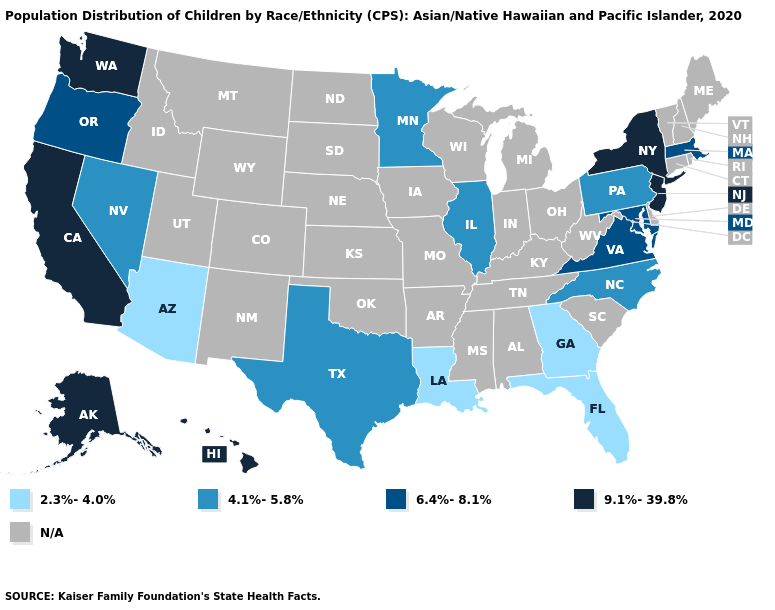What is the lowest value in the MidWest?
Quick response, please. 4.1%-5.8%. What is the value of South Carolina?
Quick response, please. N/A. Name the states that have a value in the range N/A?
Short answer required. Alabama, Arkansas, Colorado, Connecticut, Delaware, Idaho, Indiana, Iowa, Kansas, Kentucky, Maine, Michigan, Mississippi, Missouri, Montana, Nebraska, New Hampshire, New Mexico, North Dakota, Ohio, Oklahoma, Rhode Island, South Carolina, South Dakota, Tennessee, Utah, Vermont, West Virginia, Wisconsin, Wyoming. Name the states that have a value in the range 6.4%-8.1%?
Give a very brief answer. Maryland, Massachusetts, Oregon, Virginia. Name the states that have a value in the range N/A?
Be succinct. Alabama, Arkansas, Colorado, Connecticut, Delaware, Idaho, Indiana, Iowa, Kansas, Kentucky, Maine, Michigan, Mississippi, Missouri, Montana, Nebraska, New Hampshire, New Mexico, North Dakota, Ohio, Oklahoma, Rhode Island, South Carolina, South Dakota, Tennessee, Utah, Vermont, West Virginia, Wisconsin, Wyoming. Which states hav the highest value in the Northeast?
Short answer required. New Jersey, New York. Does Pennsylvania have the lowest value in the Northeast?
Write a very short answer. Yes. Which states have the lowest value in the USA?
Answer briefly. Arizona, Florida, Georgia, Louisiana. Name the states that have a value in the range 4.1%-5.8%?
Give a very brief answer. Illinois, Minnesota, Nevada, North Carolina, Pennsylvania, Texas. Name the states that have a value in the range N/A?
Keep it brief. Alabama, Arkansas, Colorado, Connecticut, Delaware, Idaho, Indiana, Iowa, Kansas, Kentucky, Maine, Michigan, Mississippi, Missouri, Montana, Nebraska, New Hampshire, New Mexico, North Dakota, Ohio, Oklahoma, Rhode Island, South Carolina, South Dakota, Tennessee, Utah, Vermont, West Virginia, Wisconsin, Wyoming. 